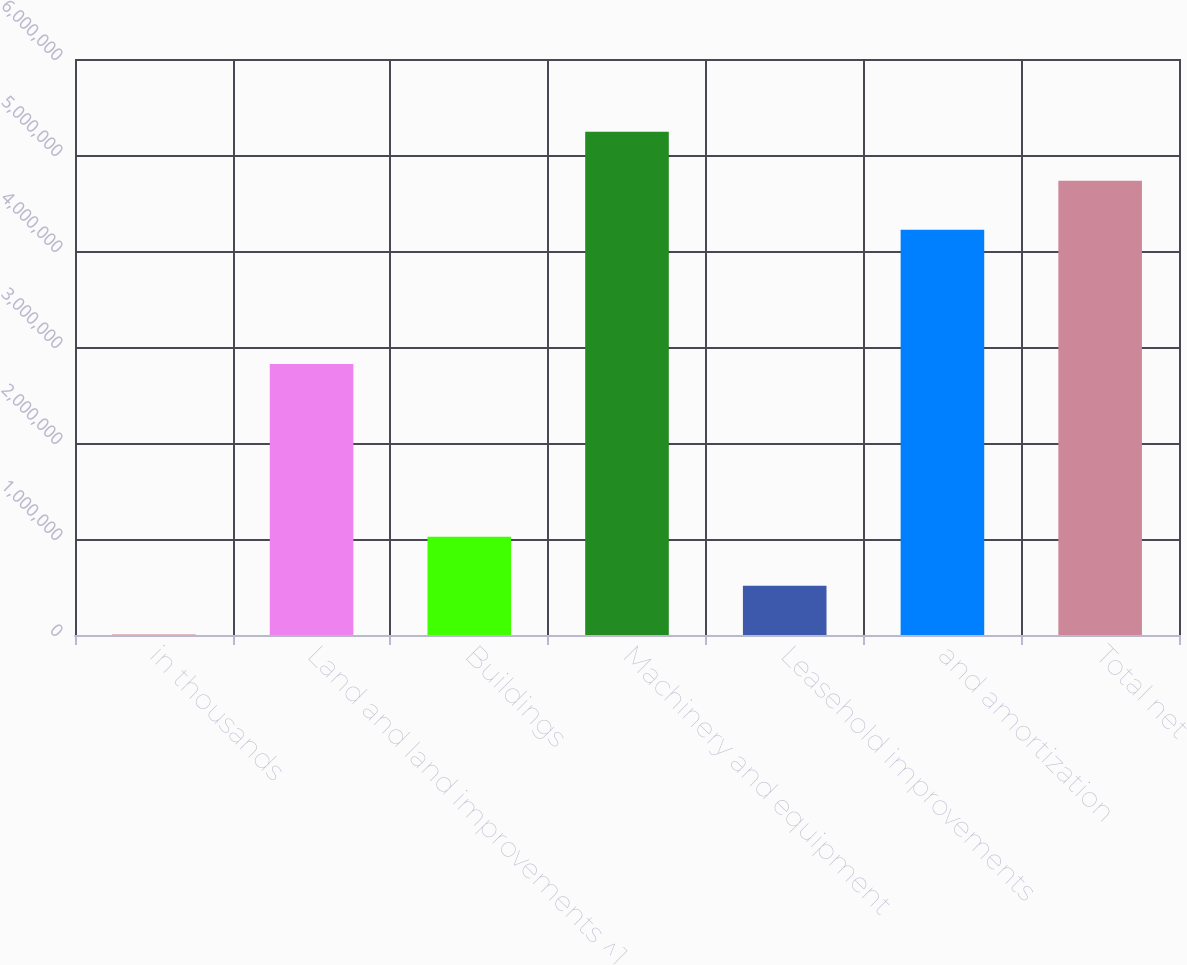Convert chart. <chart><loc_0><loc_0><loc_500><loc_500><bar_chart><fcel>in thousands<fcel>Land and land improvements ^1<fcel>Buildings<fcel>Machinery and equipment<fcel>Leasehold improvements<fcel>and amortization<fcel>Total net<nl><fcel>2018<fcel>2.82309e+06<fcel>1.023e+06<fcel>5.24129e+06<fcel>512508<fcel>4.22031e+06<fcel>4.7308e+06<nl></chart> 